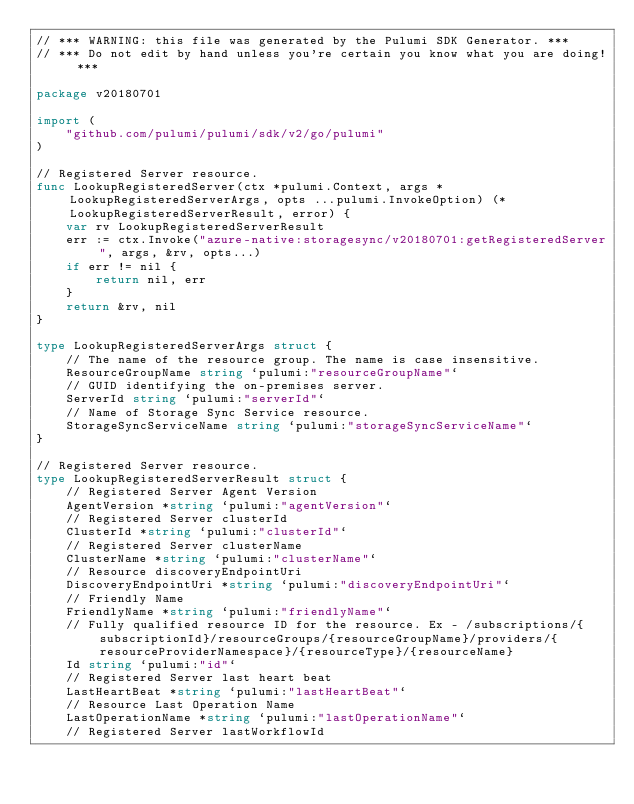Convert code to text. <code><loc_0><loc_0><loc_500><loc_500><_Go_>// *** WARNING: this file was generated by the Pulumi SDK Generator. ***
// *** Do not edit by hand unless you're certain you know what you are doing! ***

package v20180701

import (
	"github.com/pulumi/pulumi/sdk/v2/go/pulumi"
)

// Registered Server resource.
func LookupRegisteredServer(ctx *pulumi.Context, args *LookupRegisteredServerArgs, opts ...pulumi.InvokeOption) (*LookupRegisteredServerResult, error) {
	var rv LookupRegisteredServerResult
	err := ctx.Invoke("azure-native:storagesync/v20180701:getRegisteredServer", args, &rv, opts...)
	if err != nil {
		return nil, err
	}
	return &rv, nil
}

type LookupRegisteredServerArgs struct {
	// The name of the resource group. The name is case insensitive.
	ResourceGroupName string `pulumi:"resourceGroupName"`
	// GUID identifying the on-premises server.
	ServerId string `pulumi:"serverId"`
	// Name of Storage Sync Service resource.
	StorageSyncServiceName string `pulumi:"storageSyncServiceName"`
}

// Registered Server resource.
type LookupRegisteredServerResult struct {
	// Registered Server Agent Version
	AgentVersion *string `pulumi:"agentVersion"`
	// Registered Server clusterId
	ClusterId *string `pulumi:"clusterId"`
	// Registered Server clusterName
	ClusterName *string `pulumi:"clusterName"`
	// Resource discoveryEndpointUri
	DiscoveryEndpointUri *string `pulumi:"discoveryEndpointUri"`
	// Friendly Name
	FriendlyName *string `pulumi:"friendlyName"`
	// Fully qualified resource ID for the resource. Ex - /subscriptions/{subscriptionId}/resourceGroups/{resourceGroupName}/providers/{resourceProviderNamespace}/{resourceType}/{resourceName}
	Id string `pulumi:"id"`
	// Registered Server last heart beat
	LastHeartBeat *string `pulumi:"lastHeartBeat"`
	// Resource Last Operation Name
	LastOperationName *string `pulumi:"lastOperationName"`
	// Registered Server lastWorkflowId</code> 